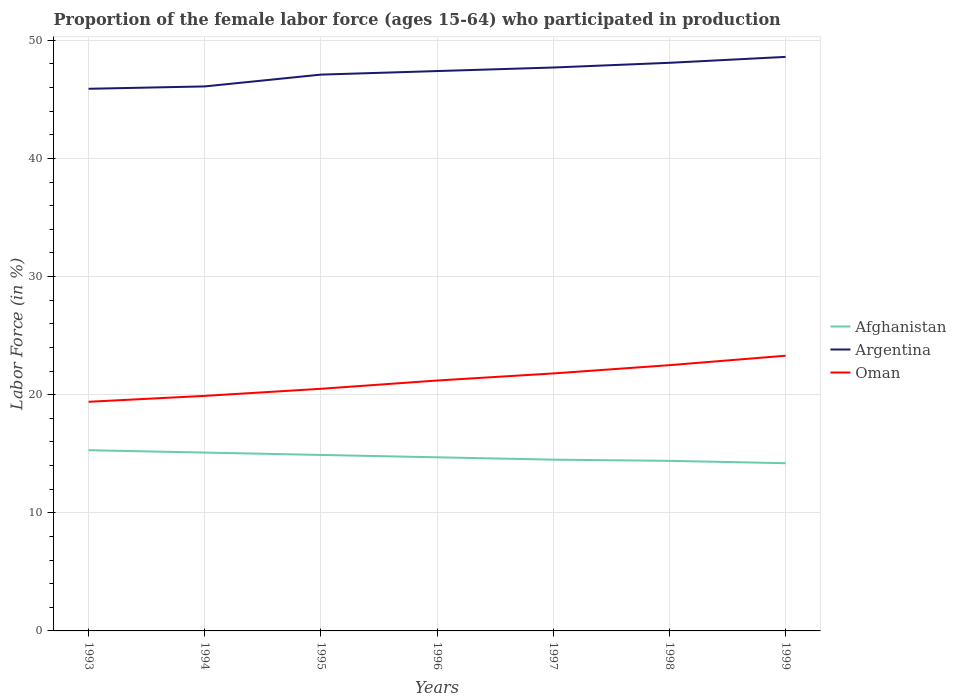Does the line corresponding to Argentina intersect with the line corresponding to Afghanistan?
Ensure brevity in your answer.  No. Is the number of lines equal to the number of legend labels?
Give a very brief answer. Yes. Across all years, what is the maximum proportion of the female labor force who participated in production in Afghanistan?
Your response must be concise. 14.2. In which year was the proportion of the female labor force who participated in production in Argentina maximum?
Your response must be concise. 1993. What is the total proportion of the female labor force who participated in production in Afghanistan in the graph?
Offer a terse response. 0.8. What is the difference between the highest and the second highest proportion of the female labor force who participated in production in Argentina?
Offer a very short reply. 2.7. What is the difference between the highest and the lowest proportion of the female labor force who participated in production in Afghanistan?
Offer a terse response. 3. Is the proportion of the female labor force who participated in production in Afghanistan strictly greater than the proportion of the female labor force who participated in production in Argentina over the years?
Make the answer very short. Yes. What is the difference between two consecutive major ticks on the Y-axis?
Offer a terse response. 10. Where does the legend appear in the graph?
Offer a very short reply. Center right. What is the title of the graph?
Offer a terse response. Proportion of the female labor force (ages 15-64) who participated in production. What is the label or title of the Y-axis?
Provide a succinct answer. Labor Force (in %). What is the Labor Force (in %) in Afghanistan in 1993?
Your answer should be compact. 15.3. What is the Labor Force (in %) in Argentina in 1993?
Keep it short and to the point. 45.9. What is the Labor Force (in %) in Oman in 1993?
Your response must be concise. 19.4. What is the Labor Force (in %) of Afghanistan in 1994?
Your response must be concise. 15.1. What is the Labor Force (in %) in Argentina in 1994?
Your response must be concise. 46.1. What is the Labor Force (in %) of Oman in 1994?
Offer a terse response. 19.9. What is the Labor Force (in %) of Afghanistan in 1995?
Offer a very short reply. 14.9. What is the Labor Force (in %) in Argentina in 1995?
Make the answer very short. 47.1. What is the Labor Force (in %) of Afghanistan in 1996?
Provide a succinct answer. 14.7. What is the Labor Force (in %) of Argentina in 1996?
Offer a terse response. 47.4. What is the Labor Force (in %) of Oman in 1996?
Your answer should be compact. 21.2. What is the Labor Force (in %) in Afghanistan in 1997?
Offer a terse response. 14.5. What is the Labor Force (in %) of Argentina in 1997?
Your answer should be compact. 47.7. What is the Labor Force (in %) of Oman in 1997?
Give a very brief answer. 21.8. What is the Labor Force (in %) in Afghanistan in 1998?
Ensure brevity in your answer.  14.4. What is the Labor Force (in %) of Argentina in 1998?
Your answer should be compact. 48.1. What is the Labor Force (in %) in Oman in 1998?
Your answer should be compact. 22.5. What is the Labor Force (in %) of Afghanistan in 1999?
Make the answer very short. 14.2. What is the Labor Force (in %) in Argentina in 1999?
Offer a very short reply. 48.6. What is the Labor Force (in %) in Oman in 1999?
Ensure brevity in your answer.  23.3. Across all years, what is the maximum Labor Force (in %) in Afghanistan?
Your answer should be compact. 15.3. Across all years, what is the maximum Labor Force (in %) in Argentina?
Make the answer very short. 48.6. Across all years, what is the maximum Labor Force (in %) in Oman?
Your response must be concise. 23.3. Across all years, what is the minimum Labor Force (in %) in Afghanistan?
Your response must be concise. 14.2. Across all years, what is the minimum Labor Force (in %) in Argentina?
Your answer should be very brief. 45.9. Across all years, what is the minimum Labor Force (in %) in Oman?
Ensure brevity in your answer.  19.4. What is the total Labor Force (in %) of Afghanistan in the graph?
Your answer should be compact. 103.1. What is the total Labor Force (in %) of Argentina in the graph?
Give a very brief answer. 330.9. What is the total Labor Force (in %) in Oman in the graph?
Give a very brief answer. 148.6. What is the difference between the Labor Force (in %) of Argentina in 1993 and that in 1994?
Your answer should be very brief. -0.2. What is the difference between the Labor Force (in %) in Oman in 1993 and that in 1994?
Keep it short and to the point. -0.5. What is the difference between the Labor Force (in %) in Argentina in 1993 and that in 1995?
Ensure brevity in your answer.  -1.2. What is the difference between the Labor Force (in %) in Afghanistan in 1993 and that in 1996?
Offer a terse response. 0.6. What is the difference between the Labor Force (in %) in Argentina in 1993 and that in 1996?
Offer a very short reply. -1.5. What is the difference between the Labor Force (in %) of Oman in 1993 and that in 1996?
Your answer should be very brief. -1.8. What is the difference between the Labor Force (in %) of Argentina in 1993 and that in 1997?
Give a very brief answer. -1.8. What is the difference between the Labor Force (in %) of Afghanistan in 1993 and that in 1998?
Offer a very short reply. 0.9. What is the difference between the Labor Force (in %) of Argentina in 1993 and that in 1998?
Provide a short and direct response. -2.2. What is the difference between the Labor Force (in %) of Argentina in 1994 and that in 1996?
Provide a short and direct response. -1.3. What is the difference between the Labor Force (in %) in Afghanistan in 1994 and that in 1998?
Provide a short and direct response. 0.7. What is the difference between the Labor Force (in %) in Argentina in 1994 and that in 1998?
Ensure brevity in your answer.  -2. What is the difference between the Labor Force (in %) in Afghanistan in 1994 and that in 1999?
Make the answer very short. 0.9. What is the difference between the Labor Force (in %) of Afghanistan in 1995 and that in 1996?
Offer a terse response. 0.2. What is the difference between the Labor Force (in %) in Argentina in 1995 and that in 1996?
Your response must be concise. -0.3. What is the difference between the Labor Force (in %) of Oman in 1995 and that in 1996?
Your answer should be very brief. -0.7. What is the difference between the Labor Force (in %) of Oman in 1995 and that in 1997?
Make the answer very short. -1.3. What is the difference between the Labor Force (in %) in Oman in 1995 and that in 1999?
Provide a short and direct response. -2.8. What is the difference between the Labor Force (in %) of Afghanistan in 1996 and that in 1997?
Your answer should be very brief. 0.2. What is the difference between the Labor Force (in %) in Argentina in 1996 and that in 1998?
Offer a very short reply. -0.7. What is the difference between the Labor Force (in %) of Oman in 1996 and that in 1998?
Give a very brief answer. -1.3. What is the difference between the Labor Force (in %) of Oman in 1996 and that in 1999?
Keep it short and to the point. -2.1. What is the difference between the Labor Force (in %) in Oman in 1997 and that in 1998?
Your answer should be very brief. -0.7. What is the difference between the Labor Force (in %) of Oman in 1997 and that in 1999?
Provide a succinct answer. -1.5. What is the difference between the Labor Force (in %) of Argentina in 1998 and that in 1999?
Your response must be concise. -0.5. What is the difference between the Labor Force (in %) of Oman in 1998 and that in 1999?
Keep it short and to the point. -0.8. What is the difference between the Labor Force (in %) in Afghanistan in 1993 and the Labor Force (in %) in Argentina in 1994?
Your response must be concise. -30.8. What is the difference between the Labor Force (in %) in Afghanistan in 1993 and the Labor Force (in %) in Oman in 1994?
Make the answer very short. -4.6. What is the difference between the Labor Force (in %) in Argentina in 1993 and the Labor Force (in %) in Oman in 1994?
Offer a terse response. 26. What is the difference between the Labor Force (in %) in Afghanistan in 1993 and the Labor Force (in %) in Argentina in 1995?
Give a very brief answer. -31.8. What is the difference between the Labor Force (in %) in Argentina in 1993 and the Labor Force (in %) in Oman in 1995?
Give a very brief answer. 25.4. What is the difference between the Labor Force (in %) in Afghanistan in 1993 and the Labor Force (in %) in Argentina in 1996?
Your response must be concise. -32.1. What is the difference between the Labor Force (in %) of Afghanistan in 1993 and the Labor Force (in %) of Oman in 1996?
Your answer should be very brief. -5.9. What is the difference between the Labor Force (in %) in Argentina in 1993 and the Labor Force (in %) in Oman in 1996?
Provide a succinct answer. 24.7. What is the difference between the Labor Force (in %) of Afghanistan in 1993 and the Labor Force (in %) of Argentina in 1997?
Give a very brief answer. -32.4. What is the difference between the Labor Force (in %) of Afghanistan in 1993 and the Labor Force (in %) of Oman in 1997?
Give a very brief answer. -6.5. What is the difference between the Labor Force (in %) in Argentina in 1993 and the Labor Force (in %) in Oman in 1997?
Offer a terse response. 24.1. What is the difference between the Labor Force (in %) of Afghanistan in 1993 and the Labor Force (in %) of Argentina in 1998?
Ensure brevity in your answer.  -32.8. What is the difference between the Labor Force (in %) of Afghanistan in 1993 and the Labor Force (in %) of Oman in 1998?
Provide a short and direct response. -7.2. What is the difference between the Labor Force (in %) of Argentina in 1993 and the Labor Force (in %) of Oman in 1998?
Provide a short and direct response. 23.4. What is the difference between the Labor Force (in %) in Afghanistan in 1993 and the Labor Force (in %) in Argentina in 1999?
Keep it short and to the point. -33.3. What is the difference between the Labor Force (in %) of Argentina in 1993 and the Labor Force (in %) of Oman in 1999?
Your response must be concise. 22.6. What is the difference between the Labor Force (in %) in Afghanistan in 1994 and the Labor Force (in %) in Argentina in 1995?
Provide a short and direct response. -32. What is the difference between the Labor Force (in %) in Afghanistan in 1994 and the Labor Force (in %) in Oman in 1995?
Offer a very short reply. -5.4. What is the difference between the Labor Force (in %) of Argentina in 1994 and the Labor Force (in %) of Oman in 1995?
Ensure brevity in your answer.  25.6. What is the difference between the Labor Force (in %) in Afghanistan in 1994 and the Labor Force (in %) in Argentina in 1996?
Provide a short and direct response. -32.3. What is the difference between the Labor Force (in %) in Argentina in 1994 and the Labor Force (in %) in Oman in 1996?
Your answer should be very brief. 24.9. What is the difference between the Labor Force (in %) of Afghanistan in 1994 and the Labor Force (in %) of Argentina in 1997?
Give a very brief answer. -32.6. What is the difference between the Labor Force (in %) of Afghanistan in 1994 and the Labor Force (in %) of Oman in 1997?
Keep it short and to the point. -6.7. What is the difference between the Labor Force (in %) in Argentina in 1994 and the Labor Force (in %) in Oman in 1997?
Make the answer very short. 24.3. What is the difference between the Labor Force (in %) of Afghanistan in 1994 and the Labor Force (in %) of Argentina in 1998?
Your response must be concise. -33. What is the difference between the Labor Force (in %) of Argentina in 1994 and the Labor Force (in %) of Oman in 1998?
Give a very brief answer. 23.6. What is the difference between the Labor Force (in %) in Afghanistan in 1994 and the Labor Force (in %) in Argentina in 1999?
Offer a very short reply. -33.5. What is the difference between the Labor Force (in %) of Argentina in 1994 and the Labor Force (in %) of Oman in 1999?
Your response must be concise. 22.8. What is the difference between the Labor Force (in %) of Afghanistan in 1995 and the Labor Force (in %) of Argentina in 1996?
Offer a terse response. -32.5. What is the difference between the Labor Force (in %) in Afghanistan in 1995 and the Labor Force (in %) in Oman in 1996?
Offer a very short reply. -6.3. What is the difference between the Labor Force (in %) in Argentina in 1995 and the Labor Force (in %) in Oman in 1996?
Your response must be concise. 25.9. What is the difference between the Labor Force (in %) in Afghanistan in 1995 and the Labor Force (in %) in Argentina in 1997?
Provide a short and direct response. -32.8. What is the difference between the Labor Force (in %) in Afghanistan in 1995 and the Labor Force (in %) in Oman in 1997?
Give a very brief answer. -6.9. What is the difference between the Labor Force (in %) of Argentina in 1995 and the Labor Force (in %) of Oman in 1997?
Give a very brief answer. 25.3. What is the difference between the Labor Force (in %) in Afghanistan in 1995 and the Labor Force (in %) in Argentina in 1998?
Offer a terse response. -33.2. What is the difference between the Labor Force (in %) of Afghanistan in 1995 and the Labor Force (in %) of Oman in 1998?
Your answer should be very brief. -7.6. What is the difference between the Labor Force (in %) of Argentina in 1995 and the Labor Force (in %) of Oman in 1998?
Your answer should be compact. 24.6. What is the difference between the Labor Force (in %) in Afghanistan in 1995 and the Labor Force (in %) in Argentina in 1999?
Your response must be concise. -33.7. What is the difference between the Labor Force (in %) in Afghanistan in 1995 and the Labor Force (in %) in Oman in 1999?
Offer a very short reply. -8.4. What is the difference between the Labor Force (in %) of Argentina in 1995 and the Labor Force (in %) of Oman in 1999?
Keep it short and to the point. 23.8. What is the difference between the Labor Force (in %) in Afghanistan in 1996 and the Labor Force (in %) in Argentina in 1997?
Your answer should be compact. -33. What is the difference between the Labor Force (in %) in Afghanistan in 1996 and the Labor Force (in %) in Oman in 1997?
Your response must be concise. -7.1. What is the difference between the Labor Force (in %) of Argentina in 1996 and the Labor Force (in %) of Oman in 1997?
Provide a short and direct response. 25.6. What is the difference between the Labor Force (in %) of Afghanistan in 1996 and the Labor Force (in %) of Argentina in 1998?
Make the answer very short. -33.4. What is the difference between the Labor Force (in %) of Afghanistan in 1996 and the Labor Force (in %) of Oman in 1998?
Offer a terse response. -7.8. What is the difference between the Labor Force (in %) of Argentina in 1996 and the Labor Force (in %) of Oman in 1998?
Your answer should be compact. 24.9. What is the difference between the Labor Force (in %) of Afghanistan in 1996 and the Labor Force (in %) of Argentina in 1999?
Ensure brevity in your answer.  -33.9. What is the difference between the Labor Force (in %) of Argentina in 1996 and the Labor Force (in %) of Oman in 1999?
Provide a short and direct response. 24.1. What is the difference between the Labor Force (in %) of Afghanistan in 1997 and the Labor Force (in %) of Argentina in 1998?
Your answer should be compact. -33.6. What is the difference between the Labor Force (in %) in Afghanistan in 1997 and the Labor Force (in %) in Oman in 1998?
Make the answer very short. -8. What is the difference between the Labor Force (in %) of Argentina in 1997 and the Labor Force (in %) of Oman in 1998?
Ensure brevity in your answer.  25.2. What is the difference between the Labor Force (in %) of Afghanistan in 1997 and the Labor Force (in %) of Argentina in 1999?
Give a very brief answer. -34.1. What is the difference between the Labor Force (in %) of Afghanistan in 1997 and the Labor Force (in %) of Oman in 1999?
Your answer should be very brief. -8.8. What is the difference between the Labor Force (in %) of Argentina in 1997 and the Labor Force (in %) of Oman in 1999?
Your response must be concise. 24.4. What is the difference between the Labor Force (in %) of Afghanistan in 1998 and the Labor Force (in %) of Argentina in 1999?
Provide a succinct answer. -34.2. What is the difference between the Labor Force (in %) of Argentina in 1998 and the Labor Force (in %) of Oman in 1999?
Make the answer very short. 24.8. What is the average Labor Force (in %) in Afghanistan per year?
Your answer should be compact. 14.73. What is the average Labor Force (in %) of Argentina per year?
Give a very brief answer. 47.27. What is the average Labor Force (in %) in Oman per year?
Ensure brevity in your answer.  21.23. In the year 1993, what is the difference between the Labor Force (in %) in Afghanistan and Labor Force (in %) in Argentina?
Offer a terse response. -30.6. In the year 1993, what is the difference between the Labor Force (in %) of Argentina and Labor Force (in %) of Oman?
Provide a succinct answer. 26.5. In the year 1994, what is the difference between the Labor Force (in %) of Afghanistan and Labor Force (in %) of Argentina?
Your answer should be compact. -31. In the year 1994, what is the difference between the Labor Force (in %) of Argentina and Labor Force (in %) of Oman?
Keep it short and to the point. 26.2. In the year 1995, what is the difference between the Labor Force (in %) in Afghanistan and Labor Force (in %) in Argentina?
Your answer should be compact. -32.2. In the year 1995, what is the difference between the Labor Force (in %) of Afghanistan and Labor Force (in %) of Oman?
Keep it short and to the point. -5.6. In the year 1995, what is the difference between the Labor Force (in %) in Argentina and Labor Force (in %) in Oman?
Your answer should be very brief. 26.6. In the year 1996, what is the difference between the Labor Force (in %) in Afghanistan and Labor Force (in %) in Argentina?
Provide a short and direct response. -32.7. In the year 1996, what is the difference between the Labor Force (in %) in Argentina and Labor Force (in %) in Oman?
Provide a succinct answer. 26.2. In the year 1997, what is the difference between the Labor Force (in %) in Afghanistan and Labor Force (in %) in Argentina?
Offer a terse response. -33.2. In the year 1997, what is the difference between the Labor Force (in %) of Argentina and Labor Force (in %) of Oman?
Provide a short and direct response. 25.9. In the year 1998, what is the difference between the Labor Force (in %) of Afghanistan and Labor Force (in %) of Argentina?
Offer a terse response. -33.7. In the year 1998, what is the difference between the Labor Force (in %) of Afghanistan and Labor Force (in %) of Oman?
Your answer should be very brief. -8.1. In the year 1998, what is the difference between the Labor Force (in %) of Argentina and Labor Force (in %) of Oman?
Keep it short and to the point. 25.6. In the year 1999, what is the difference between the Labor Force (in %) of Afghanistan and Labor Force (in %) of Argentina?
Provide a succinct answer. -34.4. In the year 1999, what is the difference between the Labor Force (in %) of Argentina and Labor Force (in %) of Oman?
Provide a succinct answer. 25.3. What is the ratio of the Labor Force (in %) in Afghanistan in 1993 to that in 1994?
Your answer should be compact. 1.01. What is the ratio of the Labor Force (in %) in Argentina in 1993 to that in 1994?
Ensure brevity in your answer.  1. What is the ratio of the Labor Force (in %) of Oman in 1993 to that in 1994?
Your answer should be compact. 0.97. What is the ratio of the Labor Force (in %) of Afghanistan in 1993 to that in 1995?
Give a very brief answer. 1.03. What is the ratio of the Labor Force (in %) of Argentina in 1993 to that in 1995?
Keep it short and to the point. 0.97. What is the ratio of the Labor Force (in %) in Oman in 1993 to that in 1995?
Keep it short and to the point. 0.95. What is the ratio of the Labor Force (in %) of Afghanistan in 1993 to that in 1996?
Give a very brief answer. 1.04. What is the ratio of the Labor Force (in %) in Argentina in 1993 to that in 1996?
Make the answer very short. 0.97. What is the ratio of the Labor Force (in %) of Oman in 1993 to that in 1996?
Offer a very short reply. 0.92. What is the ratio of the Labor Force (in %) in Afghanistan in 1993 to that in 1997?
Your response must be concise. 1.06. What is the ratio of the Labor Force (in %) in Argentina in 1993 to that in 1997?
Keep it short and to the point. 0.96. What is the ratio of the Labor Force (in %) in Oman in 1993 to that in 1997?
Offer a terse response. 0.89. What is the ratio of the Labor Force (in %) in Afghanistan in 1993 to that in 1998?
Make the answer very short. 1.06. What is the ratio of the Labor Force (in %) of Argentina in 1993 to that in 1998?
Make the answer very short. 0.95. What is the ratio of the Labor Force (in %) in Oman in 1993 to that in 1998?
Your answer should be compact. 0.86. What is the ratio of the Labor Force (in %) of Afghanistan in 1993 to that in 1999?
Your answer should be compact. 1.08. What is the ratio of the Labor Force (in %) in Argentina in 1993 to that in 1999?
Provide a short and direct response. 0.94. What is the ratio of the Labor Force (in %) in Oman in 1993 to that in 1999?
Give a very brief answer. 0.83. What is the ratio of the Labor Force (in %) in Afghanistan in 1994 to that in 1995?
Provide a succinct answer. 1.01. What is the ratio of the Labor Force (in %) of Argentina in 1994 to that in 1995?
Ensure brevity in your answer.  0.98. What is the ratio of the Labor Force (in %) of Oman in 1994 to that in 1995?
Provide a short and direct response. 0.97. What is the ratio of the Labor Force (in %) of Afghanistan in 1994 to that in 1996?
Offer a very short reply. 1.03. What is the ratio of the Labor Force (in %) in Argentina in 1994 to that in 1996?
Ensure brevity in your answer.  0.97. What is the ratio of the Labor Force (in %) in Oman in 1994 to that in 1996?
Your response must be concise. 0.94. What is the ratio of the Labor Force (in %) of Afghanistan in 1994 to that in 1997?
Make the answer very short. 1.04. What is the ratio of the Labor Force (in %) of Argentina in 1994 to that in 1997?
Give a very brief answer. 0.97. What is the ratio of the Labor Force (in %) of Oman in 1994 to that in 1997?
Keep it short and to the point. 0.91. What is the ratio of the Labor Force (in %) of Afghanistan in 1994 to that in 1998?
Your answer should be very brief. 1.05. What is the ratio of the Labor Force (in %) of Argentina in 1994 to that in 1998?
Ensure brevity in your answer.  0.96. What is the ratio of the Labor Force (in %) in Oman in 1994 to that in 1998?
Offer a very short reply. 0.88. What is the ratio of the Labor Force (in %) of Afghanistan in 1994 to that in 1999?
Offer a terse response. 1.06. What is the ratio of the Labor Force (in %) of Argentina in 1994 to that in 1999?
Make the answer very short. 0.95. What is the ratio of the Labor Force (in %) of Oman in 1994 to that in 1999?
Offer a terse response. 0.85. What is the ratio of the Labor Force (in %) of Afghanistan in 1995 to that in 1996?
Your answer should be compact. 1.01. What is the ratio of the Labor Force (in %) of Oman in 1995 to that in 1996?
Provide a short and direct response. 0.97. What is the ratio of the Labor Force (in %) in Afghanistan in 1995 to that in 1997?
Offer a terse response. 1.03. What is the ratio of the Labor Force (in %) of Argentina in 1995 to that in 1997?
Ensure brevity in your answer.  0.99. What is the ratio of the Labor Force (in %) of Oman in 1995 to that in 1997?
Your answer should be very brief. 0.94. What is the ratio of the Labor Force (in %) in Afghanistan in 1995 to that in 1998?
Keep it short and to the point. 1.03. What is the ratio of the Labor Force (in %) of Argentina in 1995 to that in 1998?
Your answer should be compact. 0.98. What is the ratio of the Labor Force (in %) in Oman in 1995 to that in 1998?
Your response must be concise. 0.91. What is the ratio of the Labor Force (in %) of Afghanistan in 1995 to that in 1999?
Make the answer very short. 1.05. What is the ratio of the Labor Force (in %) of Argentina in 1995 to that in 1999?
Provide a short and direct response. 0.97. What is the ratio of the Labor Force (in %) of Oman in 1995 to that in 1999?
Give a very brief answer. 0.88. What is the ratio of the Labor Force (in %) of Afghanistan in 1996 to that in 1997?
Keep it short and to the point. 1.01. What is the ratio of the Labor Force (in %) in Oman in 1996 to that in 1997?
Provide a short and direct response. 0.97. What is the ratio of the Labor Force (in %) in Afghanistan in 1996 to that in 1998?
Give a very brief answer. 1.02. What is the ratio of the Labor Force (in %) in Argentina in 1996 to that in 1998?
Your answer should be very brief. 0.99. What is the ratio of the Labor Force (in %) of Oman in 1996 to that in 1998?
Provide a succinct answer. 0.94. What is the ratio of the Labor Force (in %) in Afghanistan in 1996 to that in 1999?
Provide a short and direct response. 1.04. What is the ratio of the Labor Force (in %) of Argentina in 1996 to that in 1999?
Provide a short and direct response. 0.98. What is the ratio of the Labor Force (in %) of Oman in 1996 to that in 1999?
Offer a terse response. 0.91. What is the ratio of the Labor Force (in %) in Afghanistan in 1997 to that in 1998?
Your answer should be compact. 1.01. What is the ratio of the Labor Force (in %) in Argentina in 1997 to that in 1998?
Make the answer very short. 0.99. What is the ratio of the Labor Force (in %) in Oman in 1997 to that in 1998?
Make the answer very short. 0.97. What is the ratio of the Labor Force (in %) of Afghanistan in 1997 to that in 1999?
Your response must be concise. 1.02. What is the ratio of the Labor Force (in %) of Argentina in 1997 to that in 1999?
Offer a very short reply. 0.98. What is the ratio of the Labor Force (in %) in Oman in 1997 to that in 1999?
Keep it short and to the point. 0.94. What is the ratio of the Labor Force (in %) of Afghanistan in 1998 to that in 1999?
Make the answer very short. 1.01. What is the ratio of the Labor Force (in %) of Oman in 1998 to that in 1999?
Your answer should be very brief. 0.97. What is the difference between the highest and the second highest Labor Force (in %) of Afghanistan?
Offer a terse response. 0.2. What is the difference between the highest and the second highest Labor Force (in %) in Oman?
Your answer should be compact. 0.8. What is the difference between the highest and the lowest Labor Force (in %) in Afghanistan?
Ensure brevity in your answer.  1.1. What is the difference between the highest and the lowest Labor Force (in %) of Oman?
Keep it short and to the point. 3.9. 